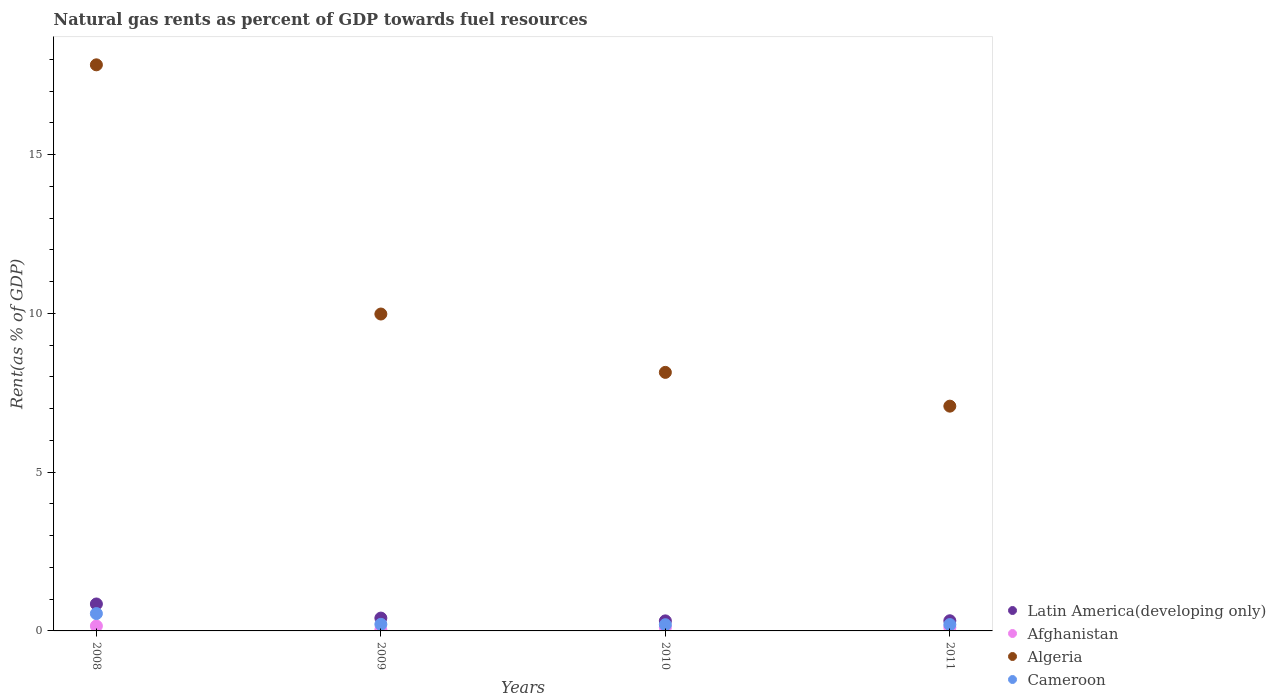What is the matural gas rent in Afghanistan in 2008?
Provide a short and direct response. 0.16. Across all years, what is the maximum matural gas rent in Afghanistan?
Give a very brief answer. 0.16. Across all years, what is the minimum matural gas rent in Cameroon?
Your response must be concise. 0.2. In which year was the matural gas rent in Cameroon maximum?
Offer a terse response. 2008. What is the total matural gas rent in Latin America(developing only) in the graph?
Offer a very short reply. 1.89. What is the difference between the matural gas rent in Cameroon in 2010 and that in 2011?
Provide a succinct answer. -0. What is the difference between the matural gas rent in Algeria in 2011 and the matural gas rent in Afghanistan in 2009?
Offer a terse response. 7.04. What is the average matural gas rent in Algeria per year?
Your response must be concise. 10.76. In the year 2009, what is the difference between the matural gas rent in Afghanistan and matural gas rent in Cameroon?
Provide a short and direct response. -0.17. In how many years, is the matural gas rent in Latin America(developing only) greater than 6 %?
Your answer should be very brief. 0. What is the ratio of the matural gas rent in Latin America(developing only) in 2008 to that in 2011?
Keep it short and to the point. 2.65. What is the difference between the highest and the second highest matural gas rent in Algeria?
Give a very brief answer. 7.85. What is the difference between the highest and the lowest matural gas rent in Algeria?
Provide a succinct answer. 10.75. In how many years, is the matural gas rent in Latin America(developing only) greater than the average matural gas rent in Latin America(developing only) taken over all years?
Keep it short and to the point. 1. Is the sum of the matural gas rent in Afghanistan in 2008 and 2009 greater than the maximum matural gas rent in Cameroon across all years?
Ensure brevity in your answer.  No. Is it the case that in every year, the sum of the matural gas rent in Latin America(developing only) and matural gas rent in Cameroon  is greater than the sum of matural gas rent in Algeria and matural gas rent in Afghanistan?
Offer a very short reply. Yes. How many dotlines are there?
Give a very brief answer. 4. How many years are there in the graph?
Ensure brevity in your answer.  4. What is the difference between two consecutive major ticks on the Y-axis?
Provide a succinct answer. 5. Are the values on the major ticks of Y-axis written in scientific E-notation?
Offer a terse response. No. Does the graph contain any zero values?
Provide a short and direct response. No. Does the graph contain grids?
Give a very brief answer. No. Where does the legend appear in the graph?
Offer a very short reply. Bottom right. How many legend labels are there?
Your answer should be very brief. 4. How are the legend labels stacked?
Make the answer very short. Vertical. What is the title of the graph?
Provide a short and direct response. Natural gas rents as percent of GDP towards fuel resources. Does "United States" appear as one of the legend labels in the graph?
Make the answer very short. No. What is the label or title of the X-axis?
Give a very brief answer. Years. What is the label or title of the Y-axis?
Ensure brevity in your answer.  Rent(as % of GDP). What is the Rent(as % of GDP) of Latin America(developing only) in 2008?
Your answer should be very brief. 0.85. What is the Rent(as % of GDP) in Afghanistan in 2008?
Your answer should be very brief. 0.16. What is the Rent(as % of GDP) of Algeria in 2008?
Keep it short and to the point. 17.82. What is the Rent(as % of GDP) in Cameroon in 2008?
Provide a short and direct response. 0.55. What is the Rent(as % of GDP) of Latin America(developing only) in 2009?
Keep it short and to the point. 0.4. What is the Rent(as % of GDP) in Afghanistan in 2009?
Ensure brevity in your answer.  0.03. What is the Rent(as % of GDP) of Algeria in 2009?
Keep it short and to the point. 9.98. What is the Rent(as % of GDP) of Cameroon in 2009?
Provide a short and direct response. 0.21. What is the Rent(as % of GDP) in Latin America(developing only) in 2010?
Offer a very short reply. 0.32. What is the Rent(as % of GDP) of Afghanistan in 2010?
Your answer should be very brief. 0.11. What is the Rent(as % of GDP) in Algeria in 2010?
Provide a short and direct response. 8.14. What is the Rent(as % of GDP) of Cameroon in 2010?
Provide a short and direct response. 0.2. What is the Rent(as % of GDP) of Latin America(developing only) in 2011?
Provide a succinct answer. 0.32. What is the Rent(as % of GDP) of Afghanistan in 2011?
Your answer should be compact. 0.11. What is the Rent(as % of GDP) in Algeria in 2011?
Provide a succinct answer. 7.08. What is the Rent(as % of GDP) of Cameroon in 2011?
Ensure brevity in your answer.  0.2. Across all years, what is the maximum Rent(as % of GDP) of Latin America(developing only)?
Ensure brevity in your answer.  0.85. Across all years, what is the maximum Rent(as % of GDP) of Afghanistan?
Give a very brief answer. 0.16. Across all years, what is the maximum Rent(as % of GDP) in Algeria?
Provide a short and direct response. 17.82. Across all years, what is the maximum Rent(as % of GDP) in Cameroon?
Give a very brief answer. 0.55. Across all years, what is the minimum Rent(as % of GDP) in Latin America(developing only)?
Keep it short and to the point. 0.32. Across all years, what is the minimum Rent(as % of GDP) in Afghanistan?
Keep it short and to the point. 0.03. Across all years, what is the minimum Rent(as % of GDP) in Algeria?
Make the answer very short. 7.08. Across all years, what is the minimum Rent(as % of GDP) of Cameroon?
Keep it short and to the point. 0.2. What is the total Rent(as % of GDP) in Latin America(developing only) in the graph?
Offer a very short reply. 1.89. What is the total Rent(as % of GDP) in Afghanistan in the graph?
Provide a short and direct response. 0.41. What is the total Rent(as % of GDP) in Algeria in the graph?
Your answer should be compact. 43.02. What is the total Rent(as % of GDP) in Cameroon in the graph?
Your response must be concise. 1.15. What is the difference between the Rent(as % of GDP) in Latin America(developing only) in 2008 and that in 2009?
Provide a succinct answer. 0.44. What is the difference between the Rent(as % of GDP) in Afghanistan in 2008 and that in 2009?
Keep it short and to the point. 0.12. What is the difference between the Rent(as % of GDP) in Algeria in 2008 and that in 2009?
Make the answer very short. 7.85. What is the difference between the Rent(as % of GDP) of Cameroon in 2008 and that in 2009?
Ensure brevity in your answer.  0.34. What is the difference between the Rent(as % of GDP) in Latin America(developing only) in 2008 and that in 2010?
Give a very brief answer. 0.53. What is the difference between the Rent(as % of GDP) in Afghanistan in 2008 and that in 2010?
Ensure brevity in your answer.  0.04. What is the difference between the Rent(as % of GDP) in Algeria in 2008 and that in 2010?
Keep it short and to the point. 9.68. What is the difference between the Rent(as % of GDP) in Cameroon in 2008 and that in 2010?
Give a very brief answer. 0.35. What is the difference between the Rent(as % of GDP) of Latin America(developing only) in 2008 and that in 2011?
Provide a short and direct response. 0.53. What is the difference between the Rent(as % of GDP) in Afghanistan in 2008 and that in 2011?
Provide a succinct answer. 0.05. What is the difference between the Rent(as % of GDP) of Algeria in 2008 and that in 2011?
Ensure brevity in your answer.  10.75. What is the difference between the Rent(as % of GDP) in Cameroon in 2008 and that in 2011?
Make the answer very short. 0.35. What is the difference between the Rent(as % of GDP) in Latin America(developing only) in 2009 and that in 2010?
Make the answer very short. 0.09. What is the difference between the Rent(as % of GDP) of Afghanistan in 2009 and that in 2010?
Give a very brief answer. -0.08. What is the difference between the Rent(as % of GDP) of Algeria in 2009 and that in 2010?
Your response must be concise. 1.84. What is the difference between the Rent(as % of GDP) in Cameroon in 2009 and that in 2010?
Give a very brief answer. 0.01. What is the difference between the Rent(as % of GDP) in Latin America(developing only) in 2009 and that in 2011?
Keep it short and to the point. 0.08. What is the difference between the Rent(as % of GDP) in Afghanistan in 2009 and that in 2011?
Provide a succinct answer. -0.07. What is the difference between the Rent(as % of GDP) of Algeria in 2009 and that in 2011?
Provide a short and direct response. 2.9. What is the difference between the Rent(as % of GDP) of Cameroon in 2009 and that in 2011?
Your answer should be compact. 0.01. What is the difference between the Rent(as % of GDP) in Latin America(developing only) in 2010 and that in 2011?
Provide a succinct answer. -0. What is the difference between the Rent(as % of GDP) of Afghanistan in 2010 and that in 2011?
Your answer should be compact. 0. What is the difference between the Rent(as % of GDP) of Algeria in 2010 and that in 2011?
Provide a succinct answer. 1.06. What is the difference between the Rent(as % of GDP) in Cameroon in 2010 and that in 2011?
Offer a very short reply. -0. What is the difference between the Rent(as % of GDP) in Latin America(developing only) in 2008 and the Rent(as % of GDP) in Afghanistan in 2009?
Offer a terse response. 0.82. What is the difference between the Rent(as % of GDP) in Latin America(developing only) in 2008 and the Rent(as % of GDP) in Algeria in 2009?
Your answer should be very brief. -9.13. What is the difference between the Rent(as % of GDP) of Latin America(developing only) in 2008 and the Rent(as % of GDP) of Cameroon in 2009?
Provide a short and direct response. 0.64. What is the difference between the Rent(as % of GDP) in Afghanistan in 2008 and the Rent(as % of GDP) in Algeria in 2009?
Your answer should be compact. -9.82. What is the difference between the Rent(as % of GDP) of Afghanistan in 2008 and the Rent(as % of GDP) of Cameroon in 2009?
Provide a succinct answer. -0.05. What is the difference between the Rent(as % of GDP) in Algeria in 2008 and the Rent(as % of GDP) in Cameroon in 2009?
Offer a terse response. 17.62. What is the difference between the Rent(as % of GDP) of Latin America(developing only) in 2008 and the Rent(as % of GDP) of Afghanistan in 2010?
Provide a short and direct response. 0.74. What is the difference between the Rent(as % of GDP) of Latin America(developing only) in 2008 and the Rent(as % of GDP) of Algeria in 2010?
Provide a succinct answer. -7.29. What is the difference between the Rent(as % of GDP) of Latin America(developing only) in 2008 and the Rent(as % of GDP) of Cameroon in 2010?
Offer a very short reply. 0.65. What is the difference between the Rent(as % of GDP) in Afghanistan in 2008 and the Rent(as % of GDP) in Algeria in 2010?
Make the answer very short. -7.99. What is the difference between the Rent(as % of GDP) of Afghanistan in 2008 and the Rent(as % of GDP) of Cameroon in 2010?
Offer a terse response. -0.04. What is the difference between the Rent(as % of GDP) in Algeria in 2008 and the Rent(as % of GDP) in Cameroon in 2010?
Make the answer very short. 17.63. What is the difference between the Rent(as % of GDP) of Latin America(developing only) in 2008 and the Rent(as % of GDP) of Afghanistan in 2011?
Your answer should be compact. 0.74. What is the difference between the Rent(as % of GDP) in Latin America(developing only) in 2008 and the Rent(as % of GDP) in Algeria in 2011?
Provide a short and direct response. -6.23. What is the difference between the Rent(as % of GDP) in Latin America(developing only) in 2008 and the Rent(as % of GDP) in Cameroon in 2011?
Offer a terse response. 0.65. What is the difference between the Rent(as % of GDP) of Afghanistan in 2008 and the Rent(as % of GDP) of Algeria in 2011?
Offer a terse response. -6.92. What is the difference between the Rent(as % of GDP) of Afghanistan in 2008 and the Rent(as % of GDP) of Cameroon in 2011?
Offer a terse response. -0.04. What is the difference between the Rent(as % of GDP) of Algeria in 2008 and the Rent(as % of GDP) of Cameroon in 2011?
Keep it short and to the point. 17.62. What is the difference between the Rent(as % of GDP) in Latin America(developing only) in 2009 and the Rent(as % of GDP) in Afghanistan in 2010?
Provide a short and direct response. 0.29. What is the difference between the Rent(as % of GDP) of Latin America(developing only) in 2009 and the Rent(as % of GDP) of Algeria in 2010?
Your answer should be very brief. -7.74. What is the difference between the Rent(as % of GDP) of Latin America(developing only) in 2009 and the Rent(as % of GDP) of Cameroon in 2010?
Give a very brief answer. 0.21. What is the difference between the Rent(as % of GDP) of Afghanistan in 2009 and the Rent(as % of GDP) of Algeria in 2010?
Give a very brief answer. -8.11. What is the difference between the Rent(as % of GDP) in Afghanistan in 2009 and the Rent(as % of GDP) in Cameroon in 2010?
Provide a succinct answer. -0.16. What is the difference between the Rent(as % of GDP) in Algeria in 2009 and the Rent(as % of GDP) in Cameroon in 2010?
Provide a succinct answer. 9.78. What is the difference between the Rent(as % of GDP) in Latin America(developing only) in 2009 and the Rent(as % of GDP) in Afghanistan in 2011?
Your answer should be compact. 0.3. What is the difference between the Rent(as % of GDP) of Latin America(developing only) in 2009 and the Rent(as % of GDP) of Algeria in 2011?
Your response must be concise. -6.67. What is the difference between the Rent(as % of GDP) in Latin America(developing only) in 2009 and the Rent(as % of GDP) in Cameroon in 2011?
Provide a short and direct response. 0.2. What is the difference between the Rent(as % of GDP) of Afghanistan in 2009 and the Rent(as % of GDP) of Algeria in 2011?
Make the answer very short. -7.04. What is the difference between the Rent(as % of GDP) of Afghanistan in 2009 and the Rent(as % of GDP) of Cameroon in 2011?
Make the answer very short. -0.17. What is the difference between the Rent(as % of GDP) of Algeria in 2009 and the Rent(as % of GDP) of Cameroon in 2011?
Provide a succinct answer. 9.78. What is the difference between the Rent(as % of GDP) in Latin America(developing only) in 2010 and the Rent(as % of GDP) in Afghanistan in 2011?
Ensure brevity in your answer.  0.21. What is the difference between the Rent(as % of GDP) in Latin America(developing only) in 2010 and the Rent(as % of GDP) in Algeria in 2011?
Give a very brief answer. -6.76. What is the difference between the Rent(as % of GDP) of Latin America(developing only) in 2010 and the Rent(as % of GDP) of Cameroon in 2011?
Provide a succinct answer. 0.12. What is the difference between the Rent(as % of GDP) of Afghanistan in 2010 and the Rent(as % of GDP) of Algeria in 2011?
Keep it short and to the point. -6.97. What is the difference between the Rent(as % of GDP) in Afghanistan in 2010 and the Rent(as % of GDP) in Cameroon in 2011?
Your answer should be very brief. -0.09. What is the difference between the Rent(as % of GDP) in Algeria in 2010 and the Rent(as % of GDP) in Cameroon in 2011?
Your answer should be compact. 7.94. What is the average Rent(as % of GDP) of Latin America(developing only) per year?
Give a very brief answer. 0.47. What is the average Rent(as % of GDP) in Afghanistan per year?
Your answer should be very brief. 0.1. What is the average Rent(as % of GDP) of Algeria per year?
Make the answer very short. 10.76. What is the average Rent(as % of GDP) of Cameroon per year?
Make the answer very short. 0.29. In the year 2008, what is the difference between the Rent(as % of GDP) of Latin America(developing only) and Rent(as % of GDP) of Afghanistan?
Your answer should be compact. 0.69. In the year 2008, what is the difference between the Rent(as % of GDP) of Latin America(developing only) and Rent(as % of GDP) of Algeria?
Offer a very short reply. -16.98. In the year 2008, what is the difference between the Rent(as % of GDP) in Latin America(developing only) and Rent(as % of GDP) in Cameroon?
Provide a succinct answer. 0.3. In the year 2008, what is the difference between the Rent(as % of GDP) of Afghanistan and Rent(as % of GDP) of Algeria?
Make the answer very short. -17.67. In the year 2008, what is the difference between the Rent(as % of GDP) of Afghanistan and Rent(as % of GDP) of Cameroon?
Provide a succinct answer. -0.39. In the year 2008, what is the difference between the Rent(as % of GDP) of Algeria and Rent(as % of GDP) of Cameroon?
Your answer should be compact. 17.28. In the year 2009, what is the difference between the Rent(as % of GDP) of Latin America(developing only) and Rent(as % of GDP) of Afghanistan?
Ensure brevity in your answer.  0.37. In the year 2009, what is the difference between the Rent(as % of GDP) in Latin America(developing only) and Rent(as % of GDP) in Algeria?
Provide a short and direct response. -9.57. In the year 2009, what is the difference between the Rent(as % of GDP) of Latin America(developing only) and Rent(as % of GDP) of Cameroon?
Your answer should be very brief. 0.2. In the year 2009, what is the difference between the Rent(as % of GDP) of Afghanistan and Rent(as % of GDP) of Algeria?
Provide a short and direct response. -9.95. In the year 2009, what is the difference between the Rent(as % of GDP) of Afghanistan and Rent(as % of GDP) of Cameroon?
Provide a short and direct response. -0.17. In the year 2009, what is the difference between the Rent(as % of GDP) of Algeria and Rent(as % of GDP) of Cameroon?
Offer a terse response. 9.77. In the year 2010, what is the difference between the Rent(as % of GDP) in Latin America(developing only) and Rent(as % of GDP) in Afghanistan?
Keep it short and to the point. 0.21. In the year 2010, what is the difference between the Rent(as % of GDP) of Latin America(developing only) and Rent(as % of GDP) of Algeria?
Your answer should be compact. -7.82. In the year 2010, what is the difference between the Rent(as % of GDP) of Latin America(developing only) and Rent(as % of GDP) of Cameroon?
Provide a short and direct response. 0.12. In the year 2010, what is the difference between the Rent(as % of GDP) in Afghanistan and Rent(as % of GDP) in Algeria?
Ensure brevity in your answer.  -8.03. In the year 2010, what is the difference between the Rent(as % of GDP) in Afghanistan and Rent(as % of GDP) in Cameroon?
Keep it short and to the point. -0.08. In the year 2010, what is the difference between the Rent(as % of GDP) of Algeria and Rent(as % of GDP) of Cameroon?
Provide a short and direct response. 7.95. In the year 2011, what is the difference between the Rent(as % of GDP) of Latin America(developing only) and Rent(as % of GDP) of Afghanistan?
Provide a short and direct response. 0.21. In the year 2011, what is the difference between the Rent(as % of GDP) of Latin America(developing only) and Rent(as % of GDP) of Algeria?
Ensure brevity in your answer.  -6.76. In the year 2011, what is the difference between the Rent(as % of GDP) in Latin America(developing only) and Rent(as % of GDP) in Cameroon?
Offer a terse response. 0.12. In the year 2011, what is the difference between the Rent(as % of GDP) of Afghanistan and Rent(as % of GDP) of Algeria?
Keep it short and to the point. -6.97. In the year 2011, what is the difference between the Rent(as % of GDP) in Afghanistan and Rent(as % of GDP) in Cameroon?
Offer a terse response. -0.09. In the year 2011, what is the difference between the Rent(as % of GDP) in Algeria and Rent(as % of GDP) in Cameroon?
Your answer should be very brief. 6.88. What is the ratio of the Rent(as % of GDP) in Latin America(developing only) in 2008 to that in 2009?
Keep it short and to the point. 2.1. What is the ratio of the Rent(as % of GDP) in Afghanistan in 2008 to that in 2009?
Give a very brief answer. 4.72. What is the ratio of the Rent(as % of GDP) of Algeria in 2008 to that in 2009?
Offer a terse response. 1.79. What is the ratio of the Rent(as % of GDP) in Cameroon in 2008 to that in 2009?
Offer a very short reply. 2.63. What is the ratio of the Rent(as % of GDP) of Latin America(developing only) in 2008 to that in 2010?
Your response must be concise. 2.68. What is the ratio of the Rent(as % of GDP) of Afghanistan in 2008 to that in 2010?
Your answer should be very brief. 1.4. What is the ratio of the Rent(as % of GDP) of Algeria in 2008 to that in 2010?
Offer a very short reply. 2.19. What is the ratio of the Rent(as % of GDP) of Cameroon in 2008 to that in 2010?
Your answer should be very brief. 2.8. What is the ratio of the Rent(as % of GDP) in Latin America(developing only) in 2008 to that in 2011?
Make the answer very short. 2.65. What is the ratio of the Rent(as % of GDP) of Afghanistan in 2008 to that in 2011?
Your response must be concise. 1.45. What is the ratio of the Rent(as % of GDP) in Algeria in 2008 to that in 2011?
Give a very brief answer. 2.52. What is the ratio of the Rent(as % of GDP) of Cameroon in 2008 to that in 2011?
Ensure brevity in your answer.  2.73. What is the ratio of the Rent(as % of GDP) in Latin America(developing only) in 2009 to that in 2010?
Provide a succinct answer. 1.28. What is the ratio of the Rent(as % of GDP) in Afghanistan in 2009 to that in 2010?
Offer a very short reply. 0.3. What is the ratio of the Rent(as % of GDP) in Algeria in 2009 to that in 2010?
Your answer should be very brief. 1.23. What is the ratio of the Rent(as % of GDP) of Cameroon in 2009 to that in 2010?
Make the answer very short. 1.06. What is the ratio of the Rent(as % of GDP) of Latin America(developing only) in 2009 to that in 2011?
Offer a very short reply. 1.26. What is the ratio of the Rent(as % of GDP) in Afghanistan in 2009 to that in 2011?
Your answer should be compact. 0.31. What is the ratio of the Rent(as % of GDP) in Algeria in 2009 to that in 2011?
Provide a short and direct response. 1.41. What is the ratio of the Rent(as % of GDP) in Cameroon in 2009 to that in 2011?
Offer a terse response. 1.04. What is the ratio of the Rent(as % of GDP) in Latin America(developing only) in 2010 to that in 2011?
Ensure brevity in your answer.  0.99. What is the ratio of the Rent(as % of GDP) of Afghanistan in 2010 to that in 2011?
Make the answer very short. 1.03. What is the ratio of the Rent(as % of GDP) of Algeria in 2010 to that in 2011?
Your answer should be very brief. 1.15. What is the ratio of the Rent(as % of GDP) in Cameroon in 2010 to that in 2011?
Provide a short and direct response. 0.98. What is the difference between the highest and the second highest Rent(as % of GDP) of Latin America(developing only)?
Give a very brief answer. 0.44. What is the difference between the highest and the second highest Rent(as % of GDP) of Afghanistan?
Your answer should be very brief. 0.04. What is the difference between the highest and the second highest Rent(as % of GDP) in Algeria?
Your answer should be very brief. 7.85. What is the difference between the highest and the second highest Rent(as % of GDP) in Cameroon?
Provide a short and direct response. 0.34. What is the difference between the highest and the lowest Rent(as % of GDP) in Latin America(developing only)?
Ensure brevity in your answer.  0.53. What is the difference between the highest and the lowest Rent(as % of GDP) in Afghanistan?
Your response must be concise. 0.12. What is the difference between the highest and the lowest Rent(as % of GDP) in Algeria?
Provide a succinct answer. 10.75. What is the difference between the highest and the lowest Rent(as % of GDP) of Cameroon?
Your response must be concise. 0.35. 